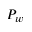<formula> <loc_0><loc_0><loc_500><loc_500>P _ { w }</formula> 